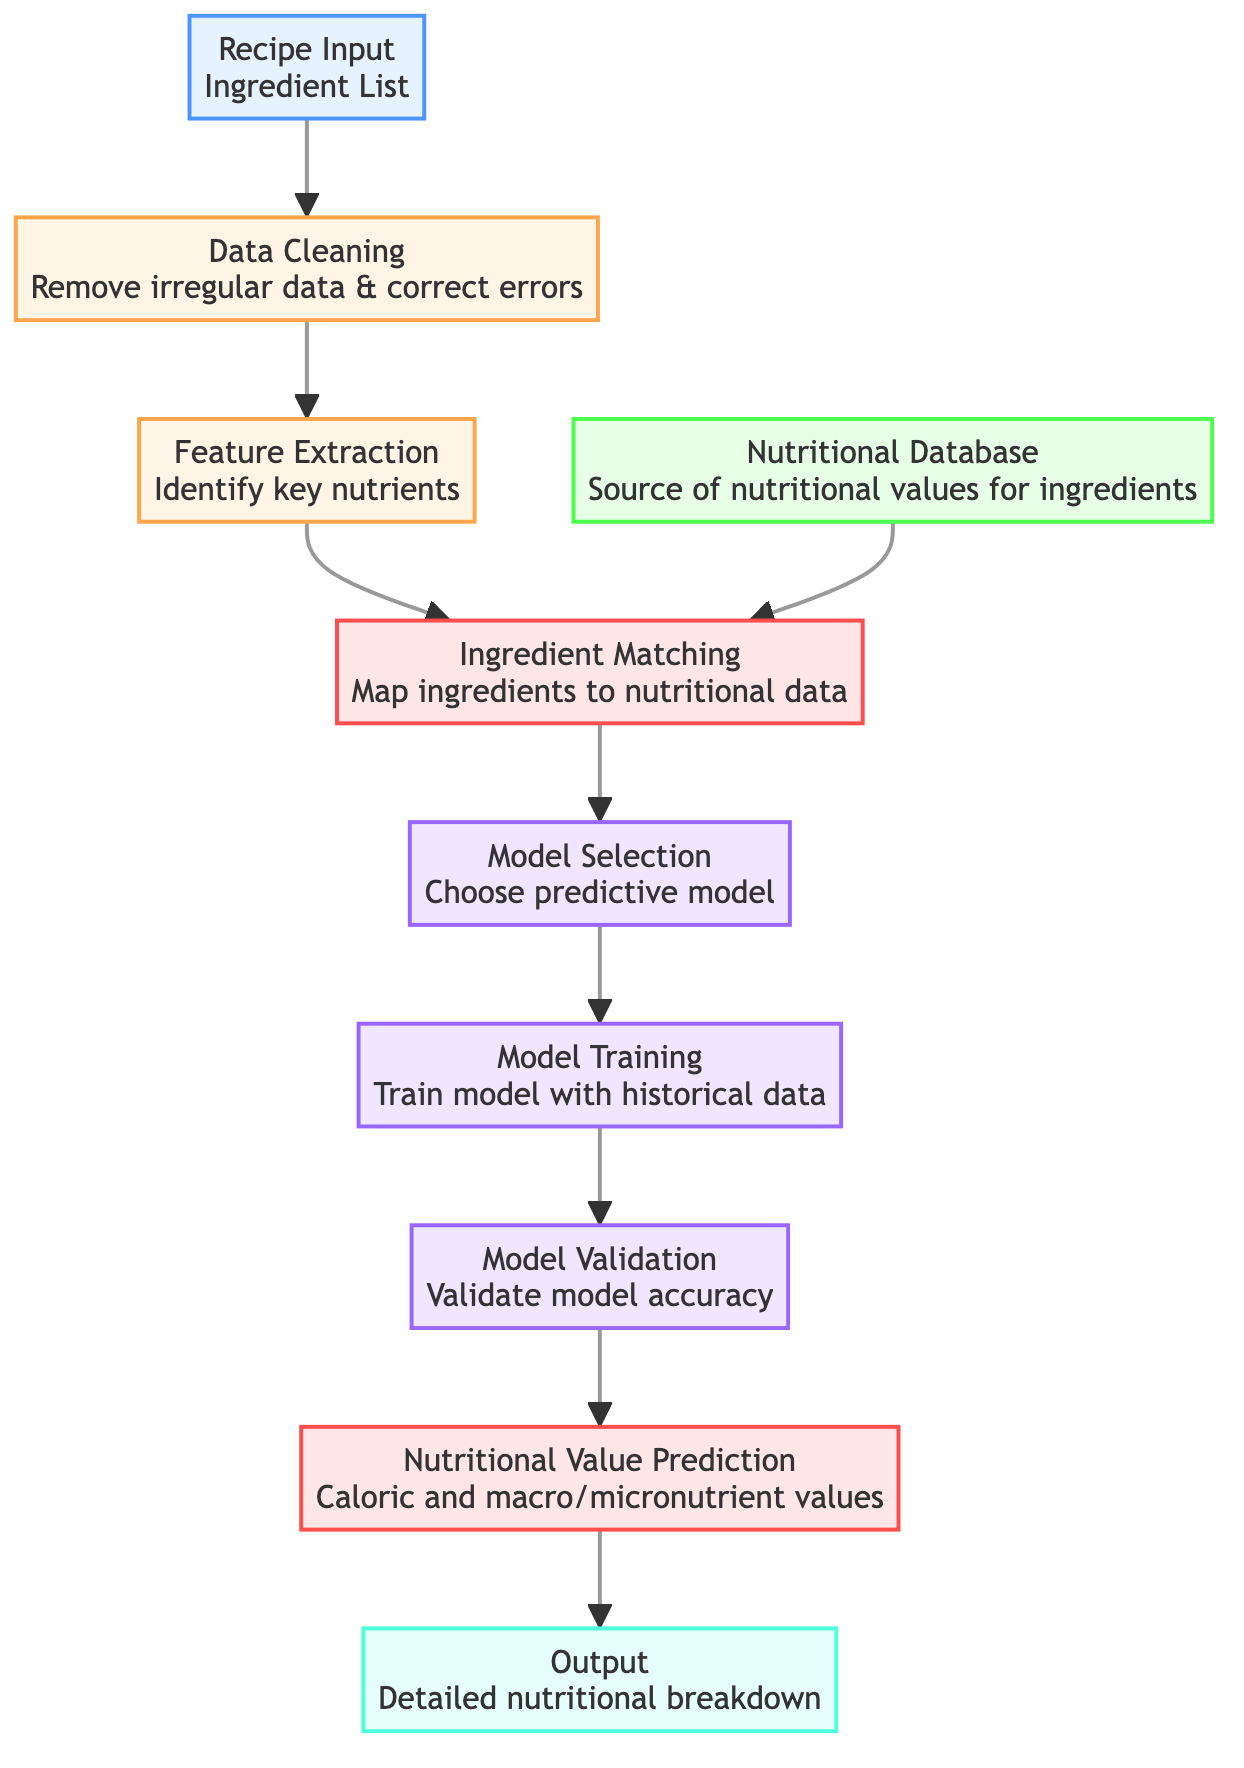What is the first step in the diagram? The first step represented in the diagram is "Recipe Input" where the input is the ingredient list. This is determined by identifying the very first node labeled A at the top.
Answer: Recipe Input How many preprocessing steps are there? There are two distinct preprocessing steps shown in the diagram: "Data Cleaning" and "Feature Extraction." These correspond to nodes B and C.
Answer: 2 Which node provides the source of nutritional values? The node labeled "Nutritional Database" labeled D provides the source of nutritional values for ingredients. It is positioned on the left side of the processing flow.
Answer: Nutritional Database What happens after ingredient matching? After the "Ingredient Matching" step represented by node E, the next step is "Model Selection" as shown in node F. This indicates that the diagram proceeds to selecting a predictive model after matching ingredients.
Answer: Model Selection What is the output of the prediction process? The output of the entire prediction process as indicated by the final node J is a "Detailed nutritional breakdown." This is what is produced as a result of the entire flow described in the diagram.
Answer: Detailed nutritional breakdown How are ingredients mapped to nutritional data? Ingredients are mapped to nutritional data through the "Ingredient Matching" step, which is listed as node E in the diagram. This node is specifically designated for this purpose, occurring after feature extraction and data cleaning.
Answer: Ingredient Matching What are the last two steps before obtaining nutritional values? The last two steps before obtaining nutritional values are "Model Validation" (node H) followed by "Nutritional Value Prediction" (node I). Analyzing the flow, these steps occur sequentially just before reaching the output.
Answer: Model Validation and Nutritional Value Prediction Which node is responsible for training the model? The node "Model Training" labeled G is responsible for training the model. It directly follows the model selection step in the processing flow.
Answer: Model Training 